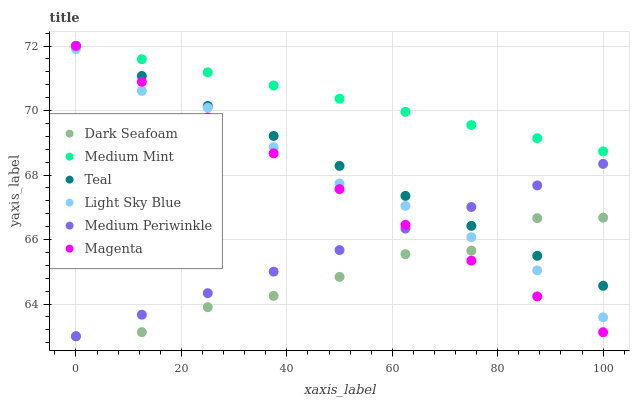Does Dark Seafoam have the minimum area under the curve?
Answer yes or no. Yes. Does Medium Mint have the maximum area under the curve?
Answer yes or no. Yes. Does Medium Periwinkle have the minimum area under the curve?
Answer yes or no. No. Does Medium Periwinkle have the maximum area under the curve?
Answer yes or no. No. Is Magenta the smoothest?
Answer yes or no. Yes. Is Dark Seafoam the roughest?
Answer yes or no. Yes. Is Medium Periwinkle the smoothest?
Answer yes or no. No. Is Medium Periwinkle the roughest?
Answer yes or no. No. Does Medium Periwinkle have the lowest value?
Answer yes or no. Yes. Does Light Sky Blue have the lowest value?
Answer yes or no. No. Does Magenta have the highest value?
Answer yes or no. Yes. Does Medium Periwinkle have the highest value?
Answer yes or no. No. Is Light Sky Blue less than Medium Mint?
Answer yes or no. Yes. Is Medium Mint greater than Light Sky Blue?
Answer yes or no. Yes. Does Magenta intersect Dark Seafoam?
Answer yes or no. Yes. Is Magenta less than Dark Seafoam?
Answer yes or no. No. Is Magenta greater than Dark Seafoam?
Answer yes or no. No. Does Light Sky Blue intersect Medium Mint?
Answer yes or no. No. 